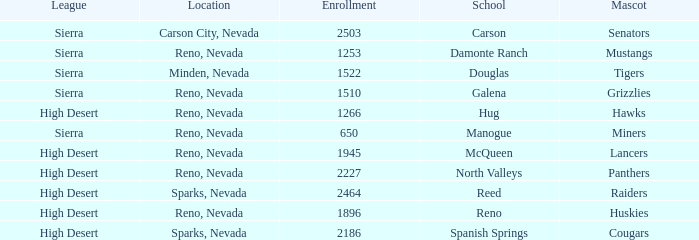Could you parse the entire table as a dict? {'header': ['League', 'Location', 'Enrollment', 'School', 'Mascot'], 'rows': [['Sierra', 'Carson City, Nevada', '2503', 'Carson', 'Senators'], ['Sierra', 'Reno, Nevada', '1253', 'Damonte Ranch', 'Mustangs'], ['Sierra', 'Minden, Nevada', '1522', 'Douglas', 'Tigers'], ['Sierra', 'Reno, Nevada', '1510', 'Galena', 'Grizzlies'], ['High Desert', 'Reno, Nevada', '1266', 'Hug', 'Hawks'], ['Sierra', 'Reno, Nevada', '650', 'Manogue', 'Miners'], ['High Desert', 'Reno, Nevada', '1945', 'McQueen', 'Lancers'], ['High Desert', 'Reno, Nevada', '2227', 'North Valleys', 'Panthers'], ['High Desert', 'Sparks, Nevada', '2464', 'Reed', 'Raiders'], ['High Desert', 'Reno, Nevada', '1896', 'Reno', 'Huskies'], ['High Desert', 'Sparks, Nevada', '2186', 'Spanish Springs', 'Cougars']]} Which leagues have Raiders as their mascot? High Desert. 